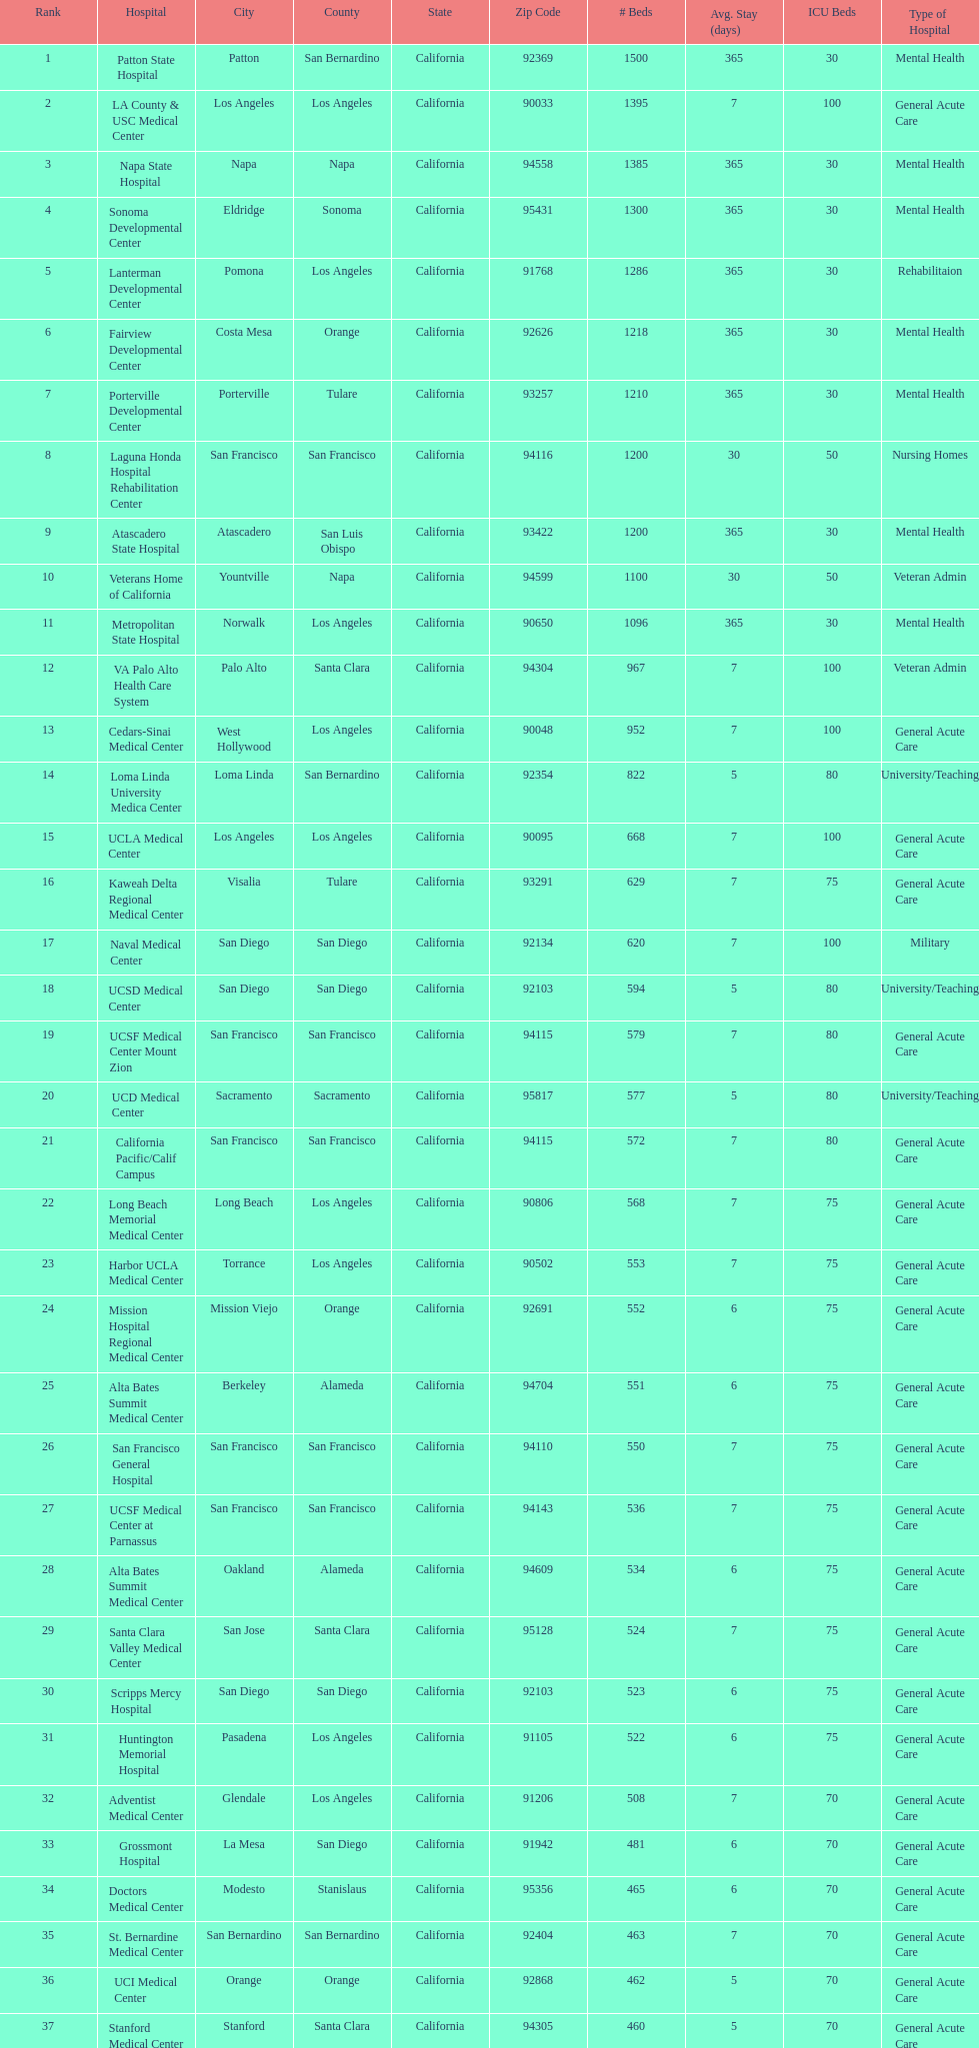Which type of hospitals are the same as grossmont hospital? General Acute Care. 